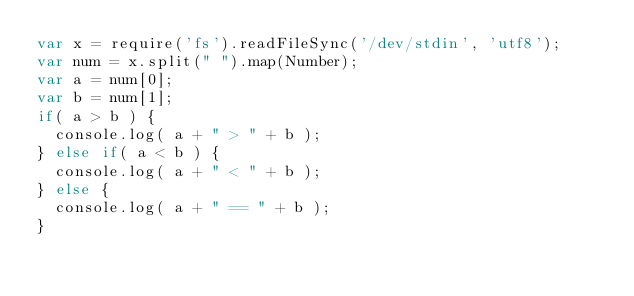<code> <loc_0><loc_0><loc_500><loc_500><_JavaScript_>var x = require('fs').readFileSync('/dev/stdin', 'utf8');
var num = x.split(" ").map(Number);
var a = num[0];
var b = num[1];
if( a > b ) {
  console.log( a + " > " + b );
} else if( a < b ) {
  console.log( a + " < " + b );
} else {
  console.log( a + " == " + b );
}</code> 